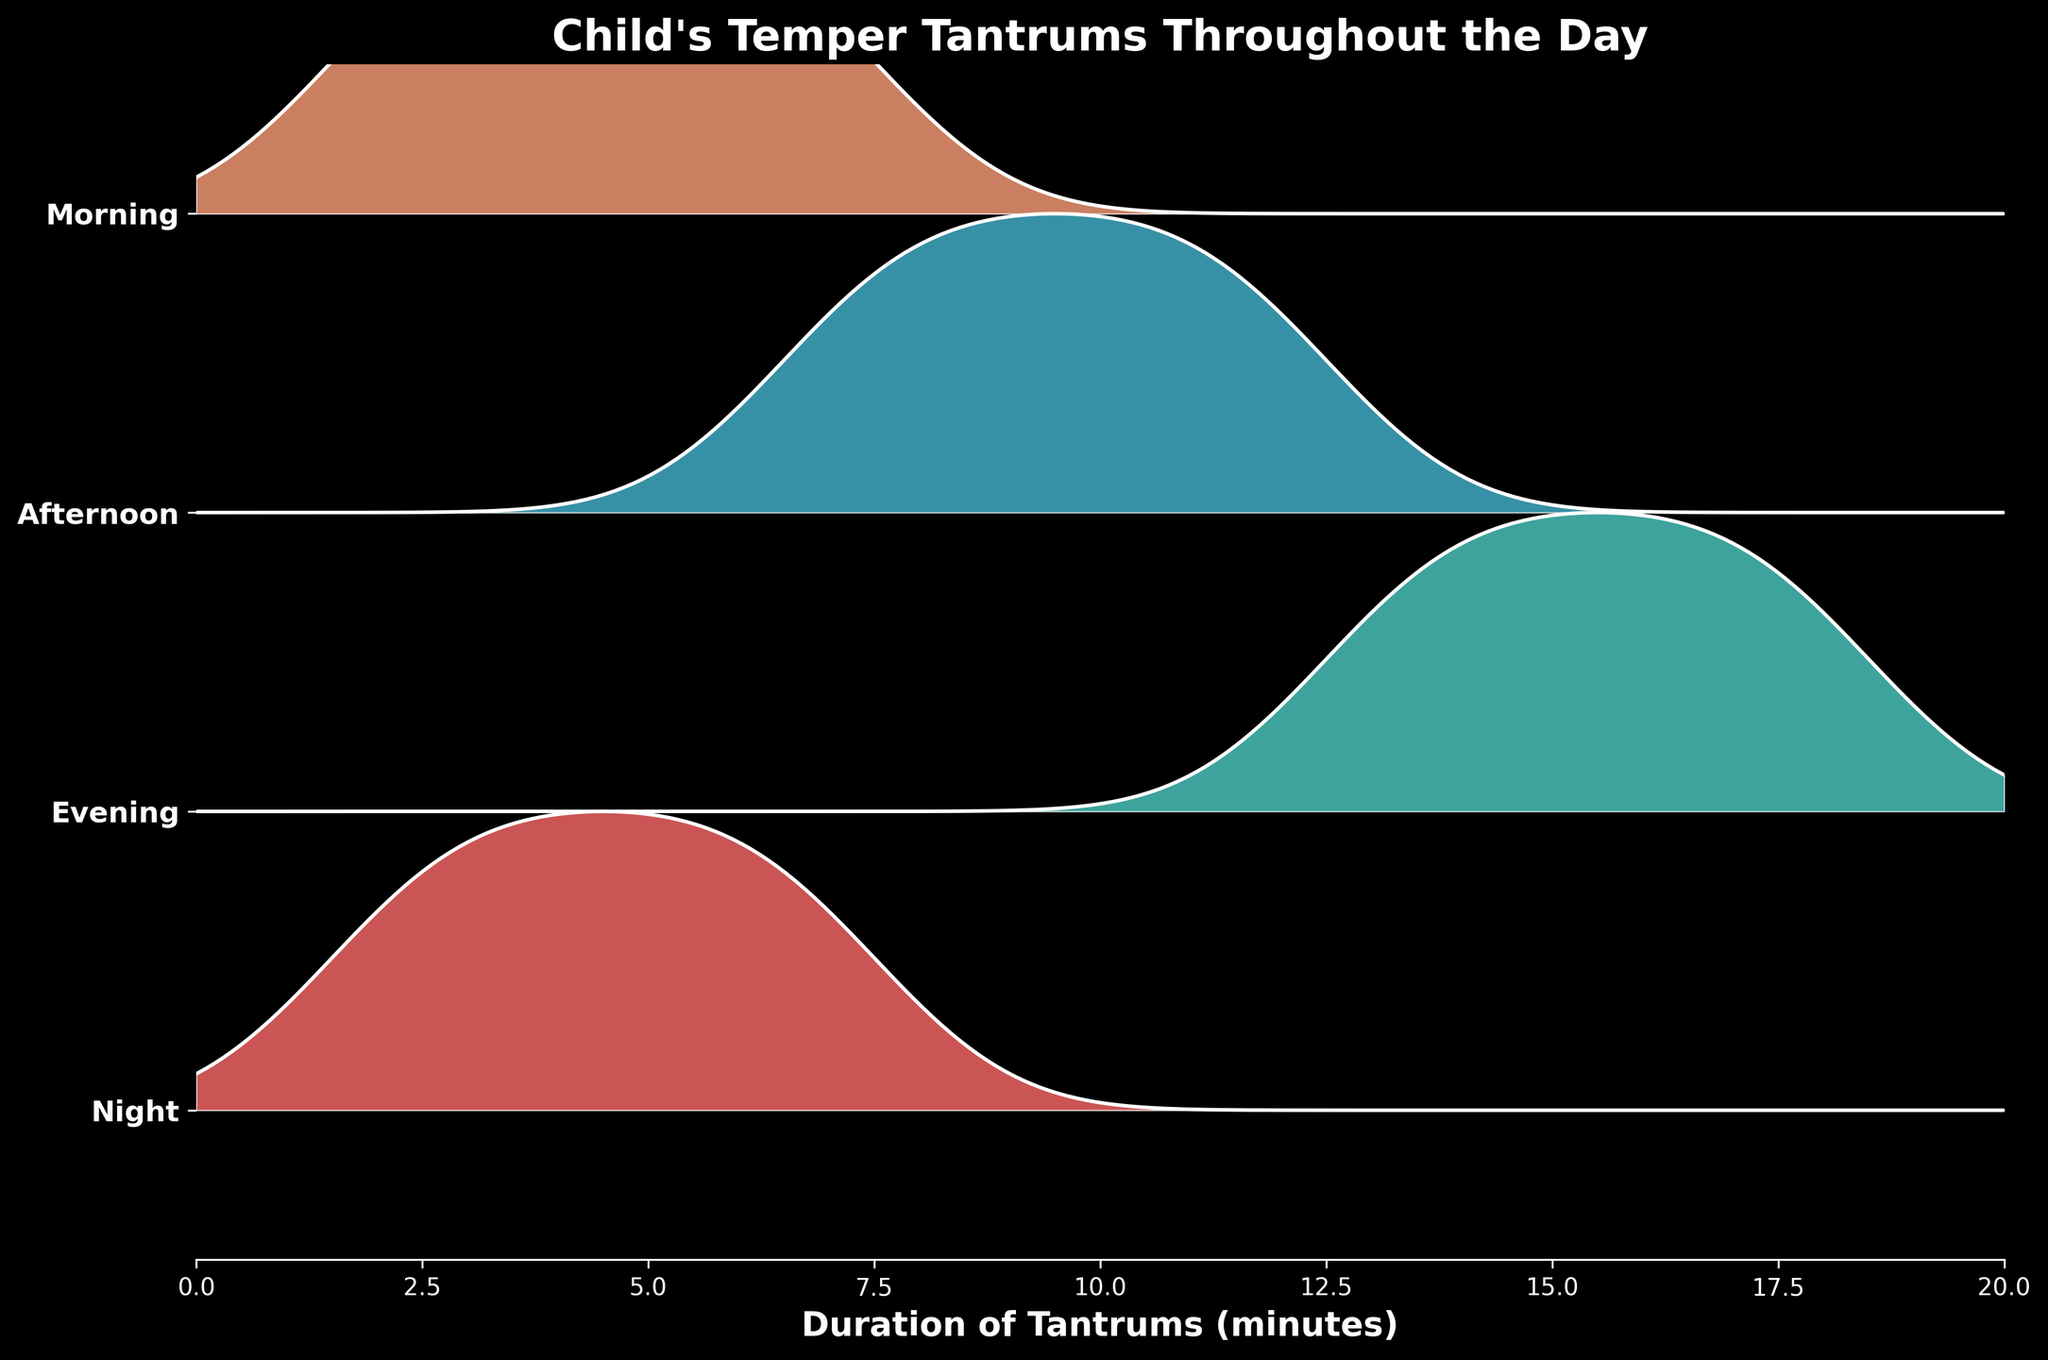What is the title of the plot? The title is displayed prominently at the top of the plot, making it easy to identify.
Answer: Child's Temper Tantrums Throughout the Day What time of day has the longest duration of temper tantrums, on average? By looking at the ridgelines, the Evening has the longest durations since it is shifted more to the right compared to other times.
Answer: Evening Which color represents the data for Morning? Each time of day is represented by a distinct color; Morning is represented by a sandy orange color.
Answer: Sandy orange In which time of day do the tantrums have the shortest durations? The ridgeline for Night is shifted more to the left, indicating that tantrums during Night are generally shorter.
Answer: Night How does the spread of tantrum durations in the Afternoon compare to those in the Evening? The Afternoon ridgeline covers a range of 7 to 12 minutes while the Evening ridgeline covers a range from 13 to 18 minutes, indicating that Evening tantrum durations are generally longer and have a wider range.
Answer: Evening has a longer and wider range What's the median duration of tantrums in the Night? The median can be approximated as it is the middle value in the sorted range of durations. Night's durations are clustered around 4 to 6 minutes.
Answer: Around 5 minutes What is the range of tantrum durations in the Morning? By looking at the Morning ridgeline, the durations range from approximately 2 to 7 minutes.
Answer: 2 to 7 minutes Compare the density shape of tantrum durations between Night and Morning. Which has a higher peak? The density shapes of Night and Morning show that Night has a sharper peak, indicating higher frequency at a specific duration (around 5 minutes) compared to Morning which has a more spread out distribution.
Answer: Night has a higher peak 